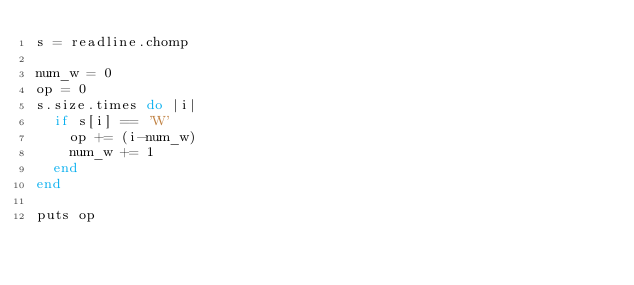Convert code to text. <code><loc_0><loc_0><loc_500><loc_500><_Ruby_>s = readline.chomp

num_w = 0
op = 0
s.size.times do |i|
  if s[i] == 'W'
    op += (i-num_w)
    num_w += 1
  end
end

puts op
</code> 